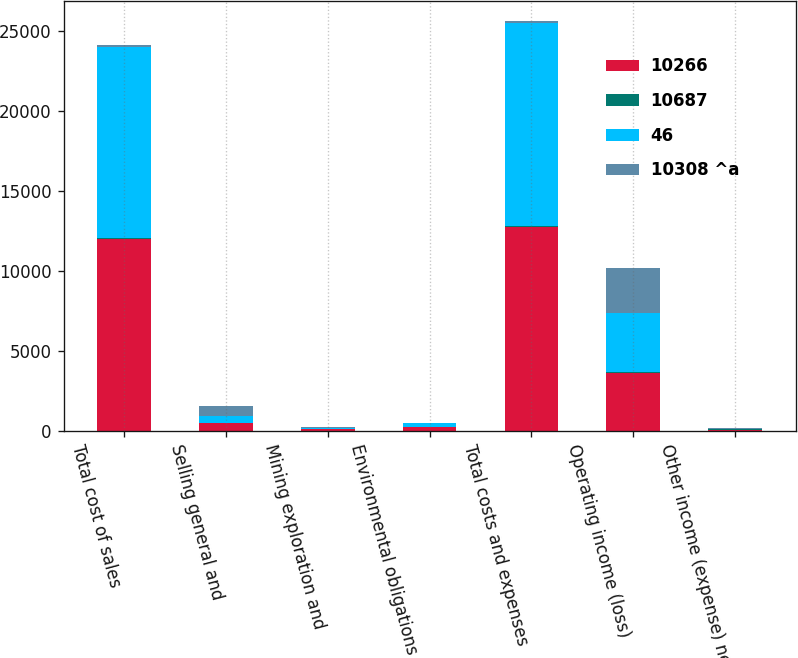Convert chart to OTSL. <chart><loc_0><loc_0><loc_500><loc_500><stacked_bar_chart><ecel><fcel>Total cost of sales<fcel>Selling general and<fcel>Mining exploration and<fcel>Environmental obligations and<fcel>Total costs and expenses<fcel>Operating income (loss)<fcel>Other income (expense) net<nl><fcel>10266<fcel>12022<fcel>484<fcel>94<fcel>251<fcel>12770<fcel>3633<fcel>49<nl><fcel>10687<fcel>42<fcel>7<fcel>1<fcel>7<fcel>57<fcel>57<fcel>57<nl><fcel>46<fcel>11980<fcel>477<fcel>93<fcel>244<fcel>12713<fcel>3690<fcel>8<nl><fcel>10308 ^a<fcel>93.5<fcel>607<fcel>64<fcel>20<fcel>93.5<fcel>2792<fcel>49<nl></chart> 